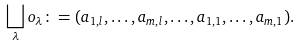Convert formula to latex. <formula><loc_0><loc_0><loc_500><loc_500>\bigsqcup _ { \lambda } o _ { \lambda } \colon = ( a _ { 1 , l } , \dots , a _ { m , l } , \dots , a _ { 1 , 1 } , \dots , a _ { m , 1 } ) .</formula> 